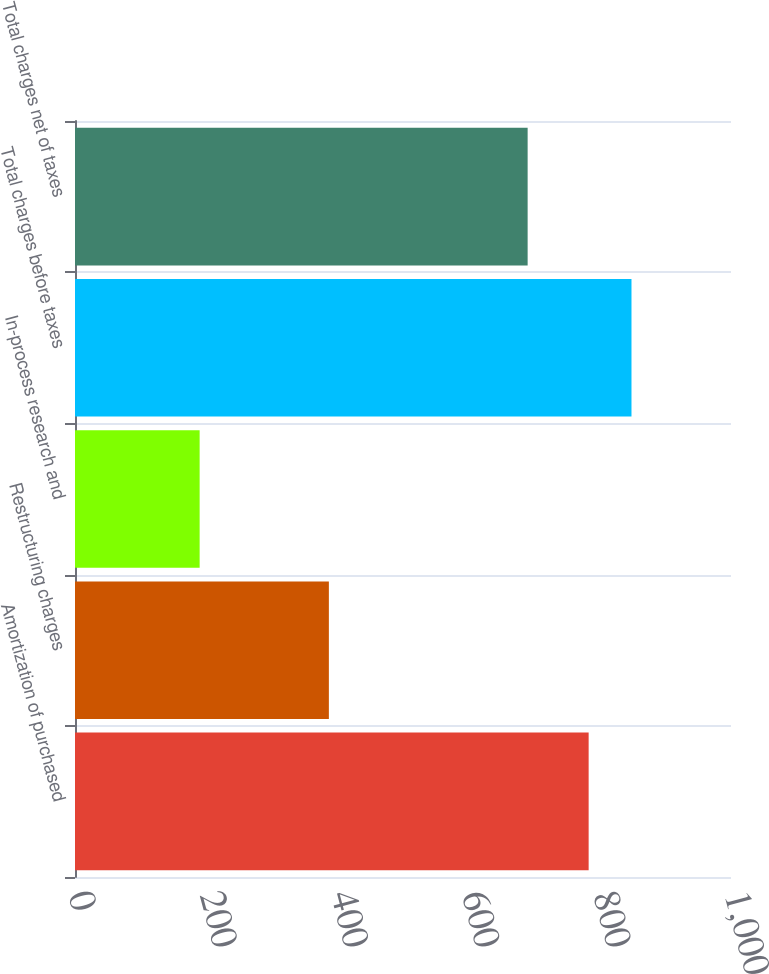<chart> <loc_0><loc_0><loc_500><loc_500><bar_chart><fcel>Amortization of purchased<fcel>Restructuring charges<fcel>In-process research and<fcel>Total charges before taxes<fcel>Total charges net of taxes<nl><fcel>783<fcel>387<fcel>190<fcel>848.3<fcel>690<nl></chart> 